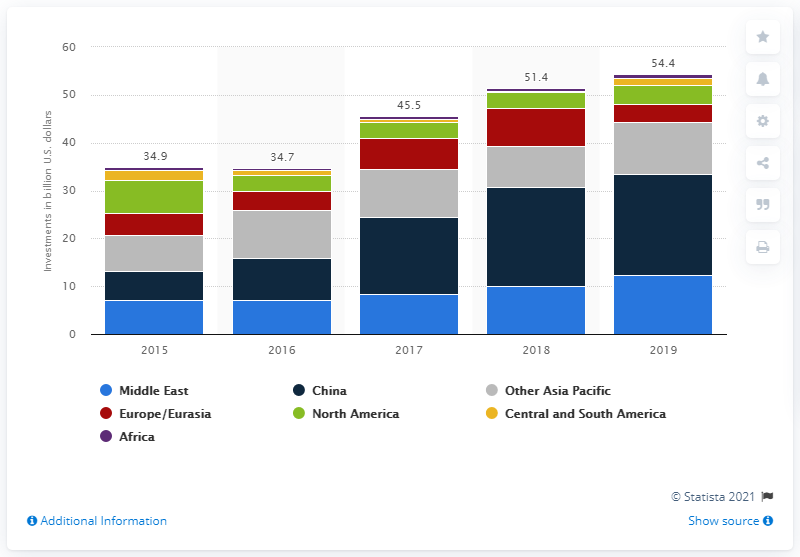Specify some key components in this picture. In 2019, China invested a significant amount in refinery capacity. 